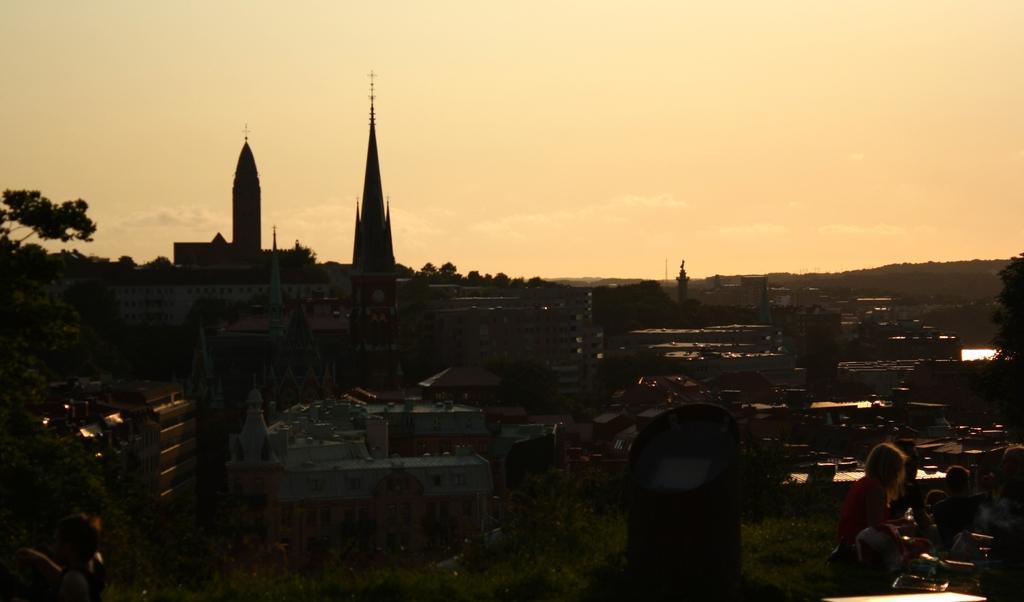Please provide a concise description of this image. In this image we can see a few people and some objects on the surface and we can see some buildings in the middle of the image. There are some trees and grass on the ground and we can see the sky at the top. 